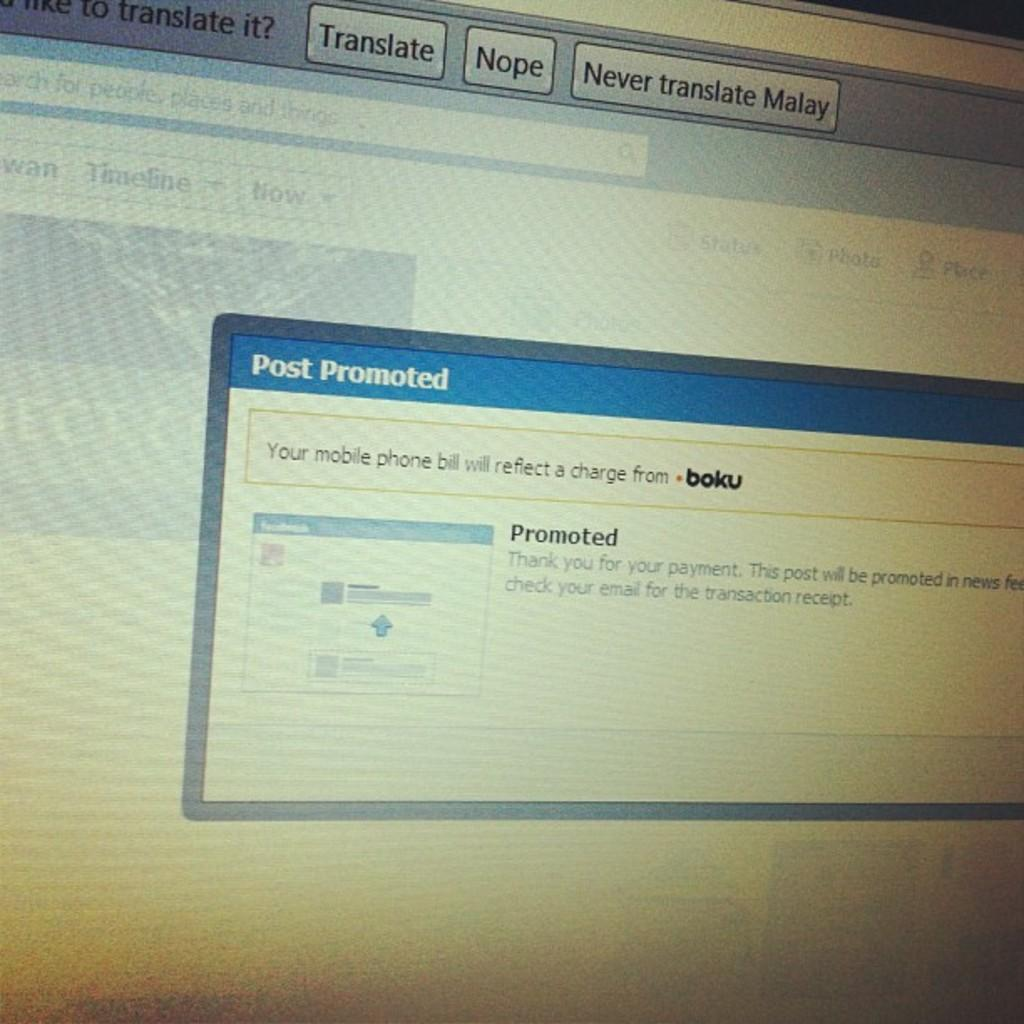<image>
Render a clear and concise summary of the photo. The computer screen asked whether or not to translate the language on the page. 